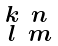Convert formula to latex. <formula><loc_0><loc_0><loc_500><loc_500>\begin{smallmatrix} k & n \\ l & m \end{smallmatrix}</formula> 